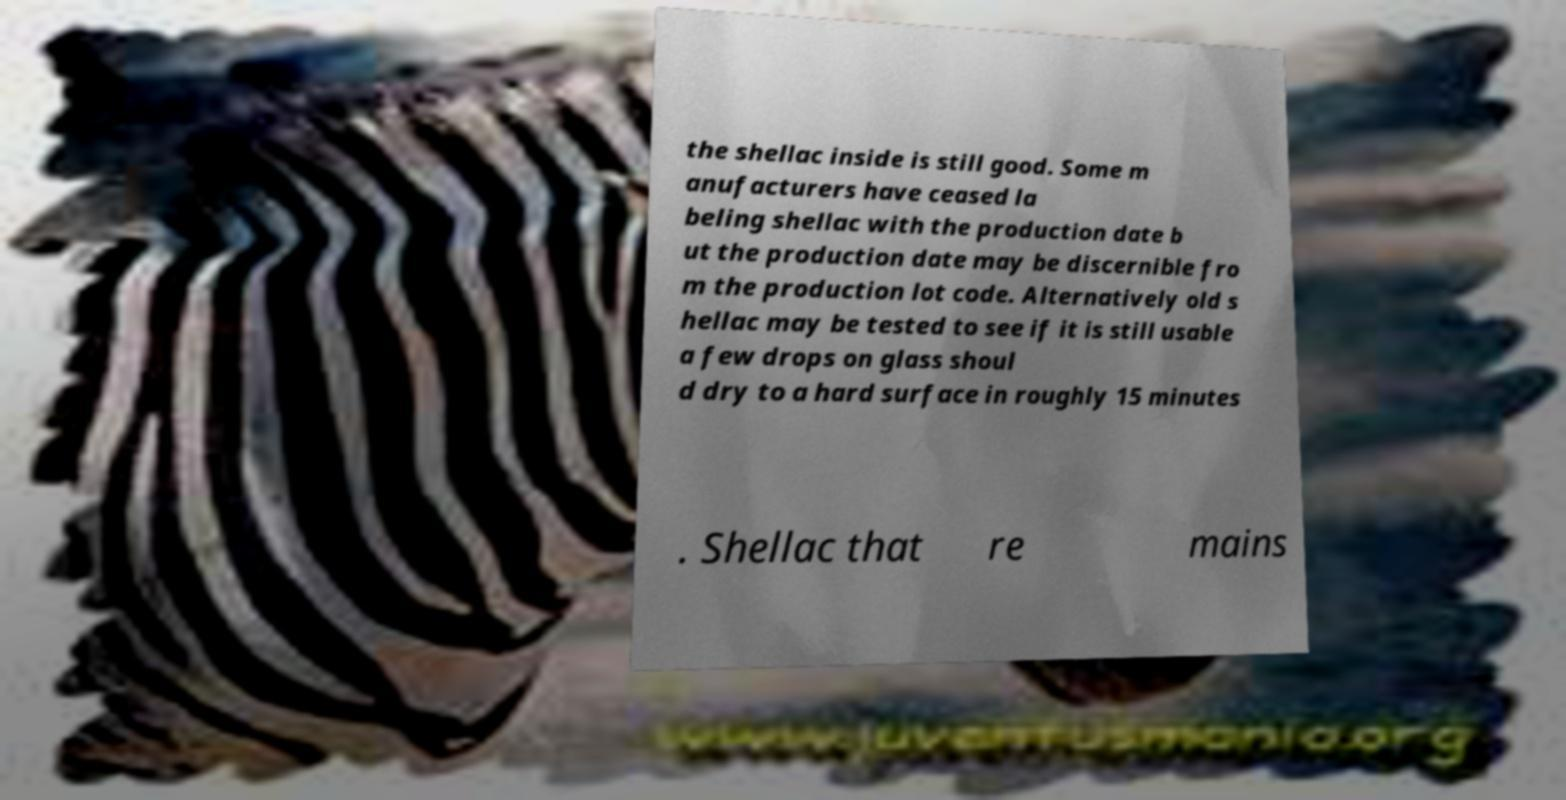Please read and relay the text visible in this image. What does it say? the shellac inside is still good. Some m anufacturers have ceased la beling shellac with the production date b ut the production date may be discernible fro m the production lot code. Alternatively old s hellac may be tested to see if it is still usable a few drops on glass shoul d dry to a hard surface in roughly 15 minutes . Shellac that re mains 